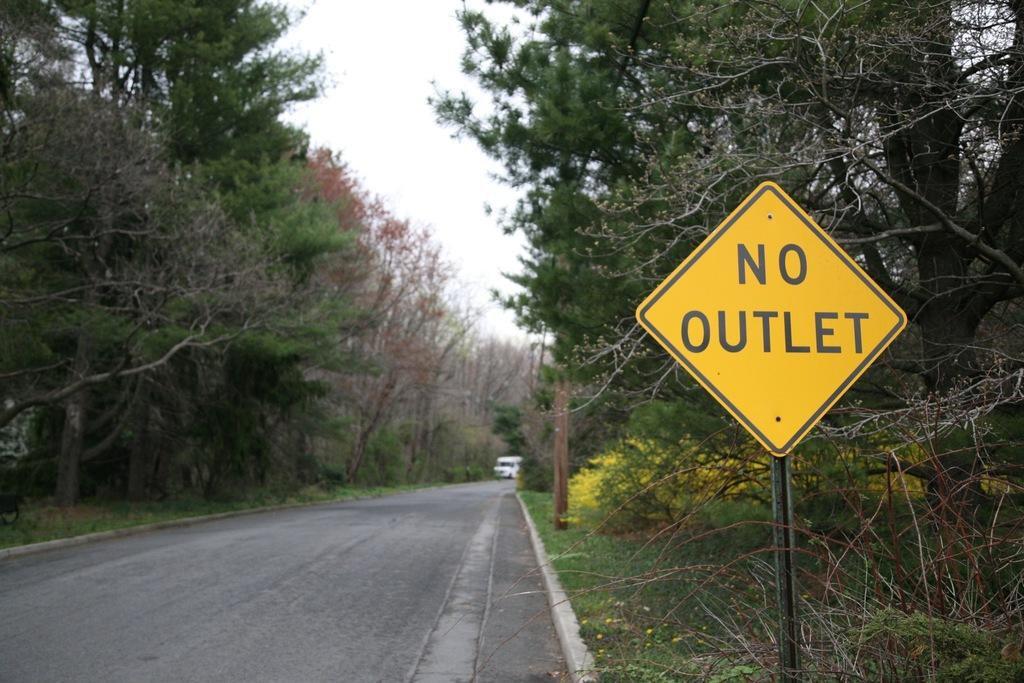<image>
Share a concise interpretation of the image provided. the word no outlet which is on the yellow sign 